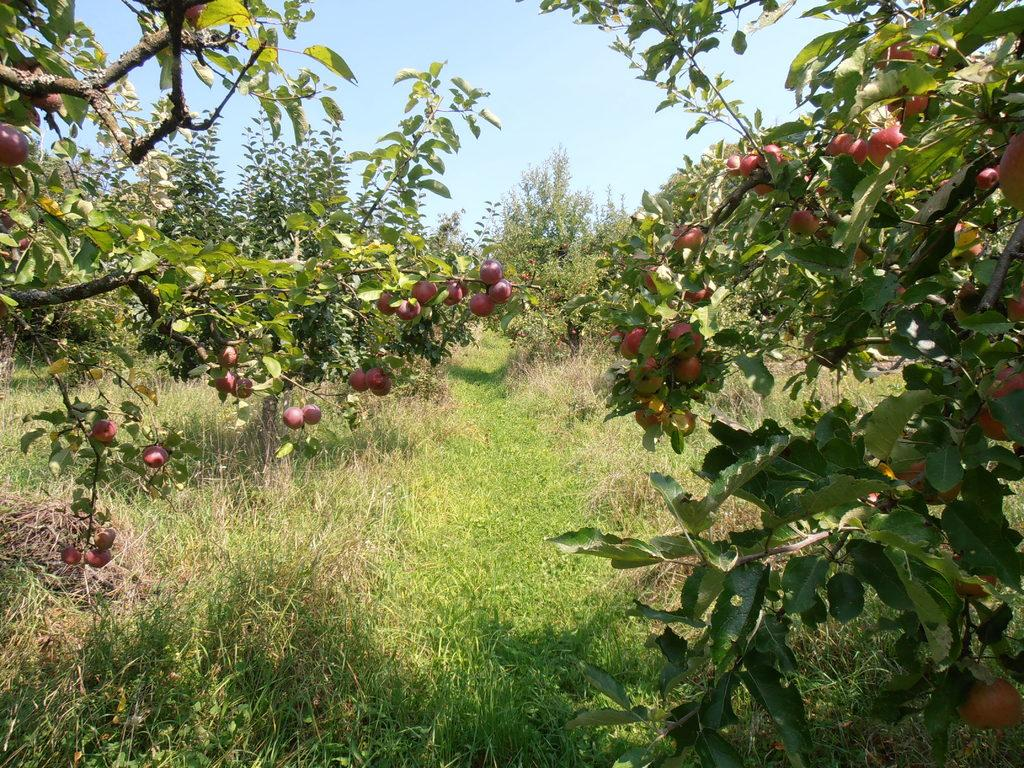What type of vegetation can be seen on the trees in the image? There are fruits on the trees in the image. Can you describe the fruits on the trees? Unfortunately, the specific type of fruits cannot be determined from the image alone. What might be the purpose of these fruits on the trees? The fruits on the trees may be for consumption by animals or humans, or they may serve a reproductive purpose for the trees themselves. What type of bottle can be seen on the tree in the image? There is no bottle present on the tree in the image; only fruits are visible. 